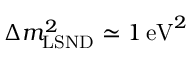Convert formula to latex. <formula><loc_0><loc_0><loc_500><loc_500>\Delta m _ { L S N D } ^ { 2 } \simeq 1 \, { e V } ^ { 2 }</formula> 